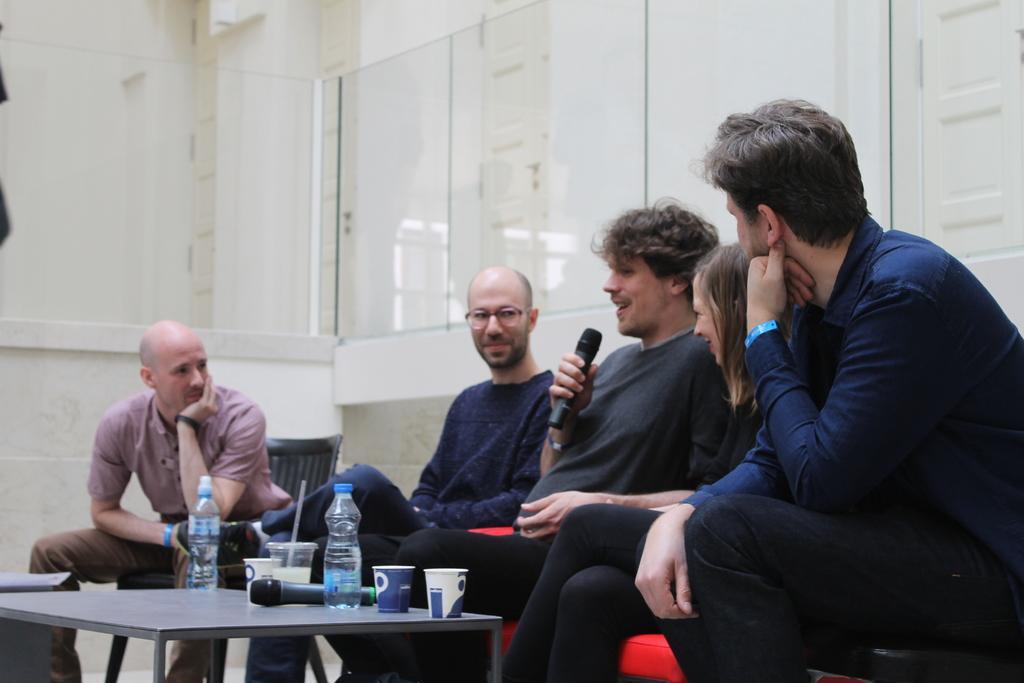Describe this image in one or two sentences. In this image I see 4 men and woman who are sitting on a couch and a chair, I see that these 3 are smiling and this man is holding a mic and there is a table in front of them on which there are 2 bottles, cups and a mic. 